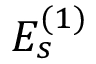Convert formula to latex. <formula><loc_0><loc_0><loc_500><loc_500>{ E } _ { s } ^ { ( 1 ) }</formula> 